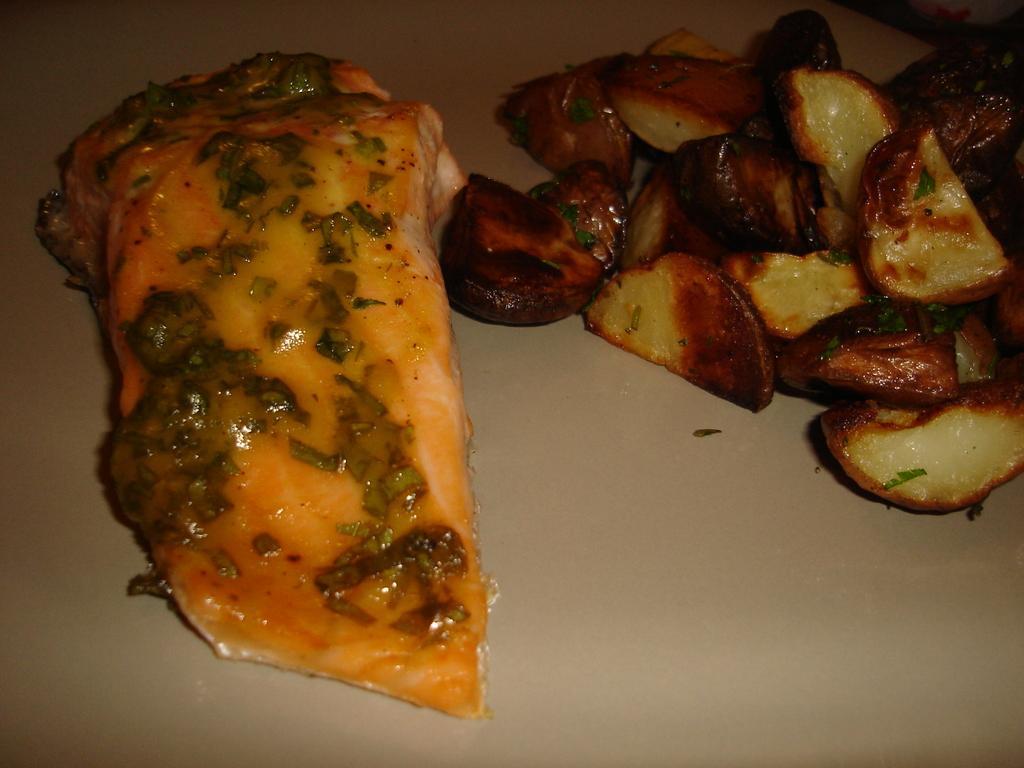Please provide a concise description of this image. These are the food pieces in a plate. 